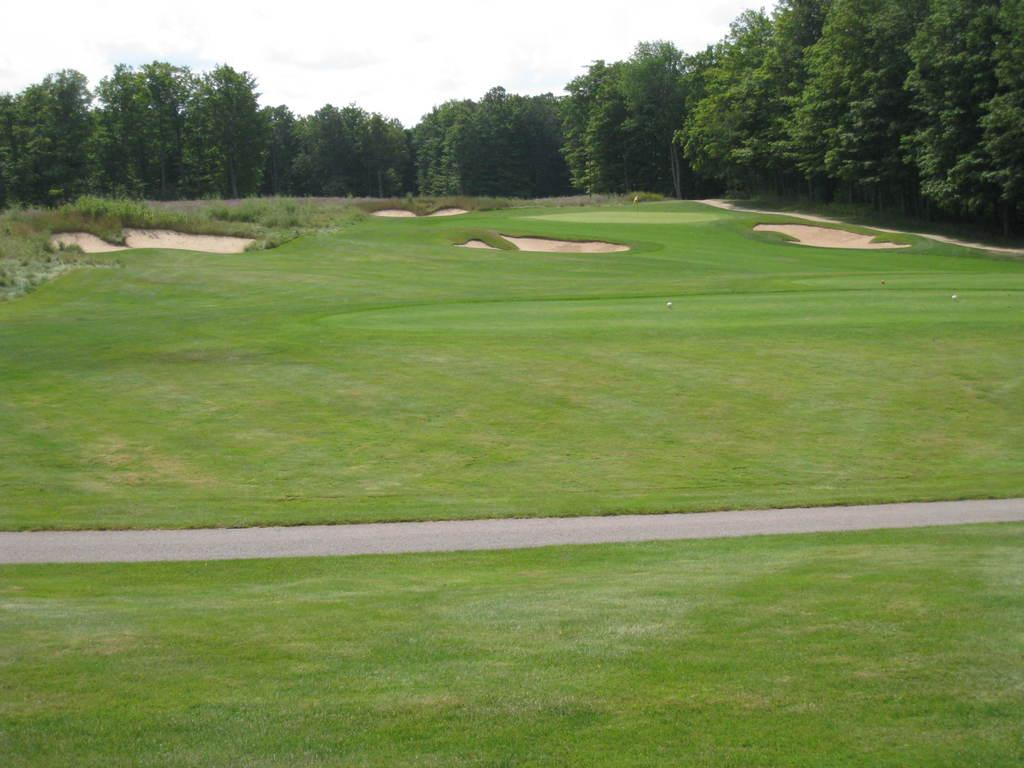What is the main feature in the foreground of the image? There is a golf court in the foreground of the image. What type of surface is present in the foreground of the image? Grass is present in the foreground of the image. Is there any path visible in the foreground of the image? Yes, there is a path in the foreground of the image. What can be seen in the background of the image? Trees and the sky are visible in the image. What type of substance is burning in the image? There is no substance burning in the image; it does not depict any flames or fire. 